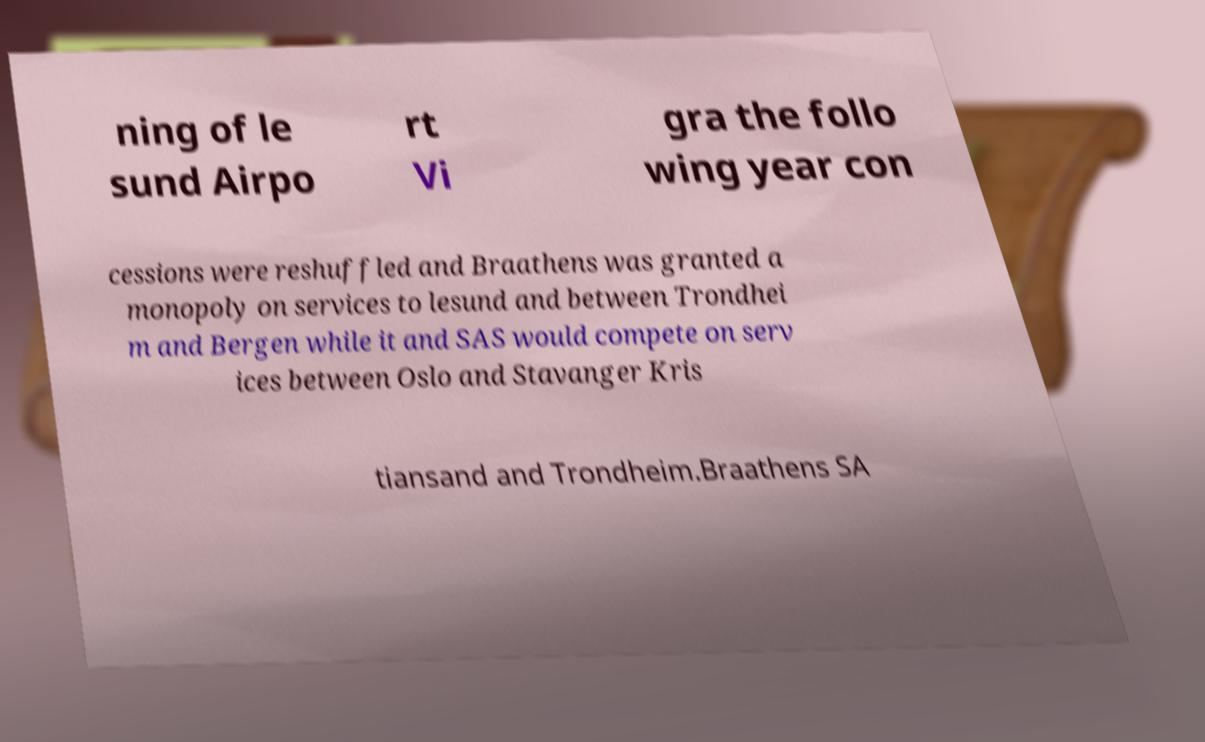What messages or text are displayed in this image? I need them in a readable, typed format. ning of le sund Airpo rt Vi gra the follo wing year con cessions were reshuffled and Braathens was granted a monopoly on services to lesund and between Trondhei m and Bergen while it and SAS would compete on serv ices between Oslo and Stavanger Kris tiansand and Trondheim.Braathens SA 